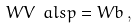Convert formula to latex. <formula><loc_0><loc_0><loc_500><loc_500>W V \ a l s p = W b \, ,</formula> 